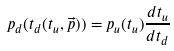Convert formula to latex. <formula><loc_0><loc_0><loc_500><loc_500>p _ { d } ( t _ { d } ( t _ { u } , \vec { p } ) ) = p _ { u } ( t _ { u } ) \frac { d t _ { u } } { d t _ { d } }</formula> 